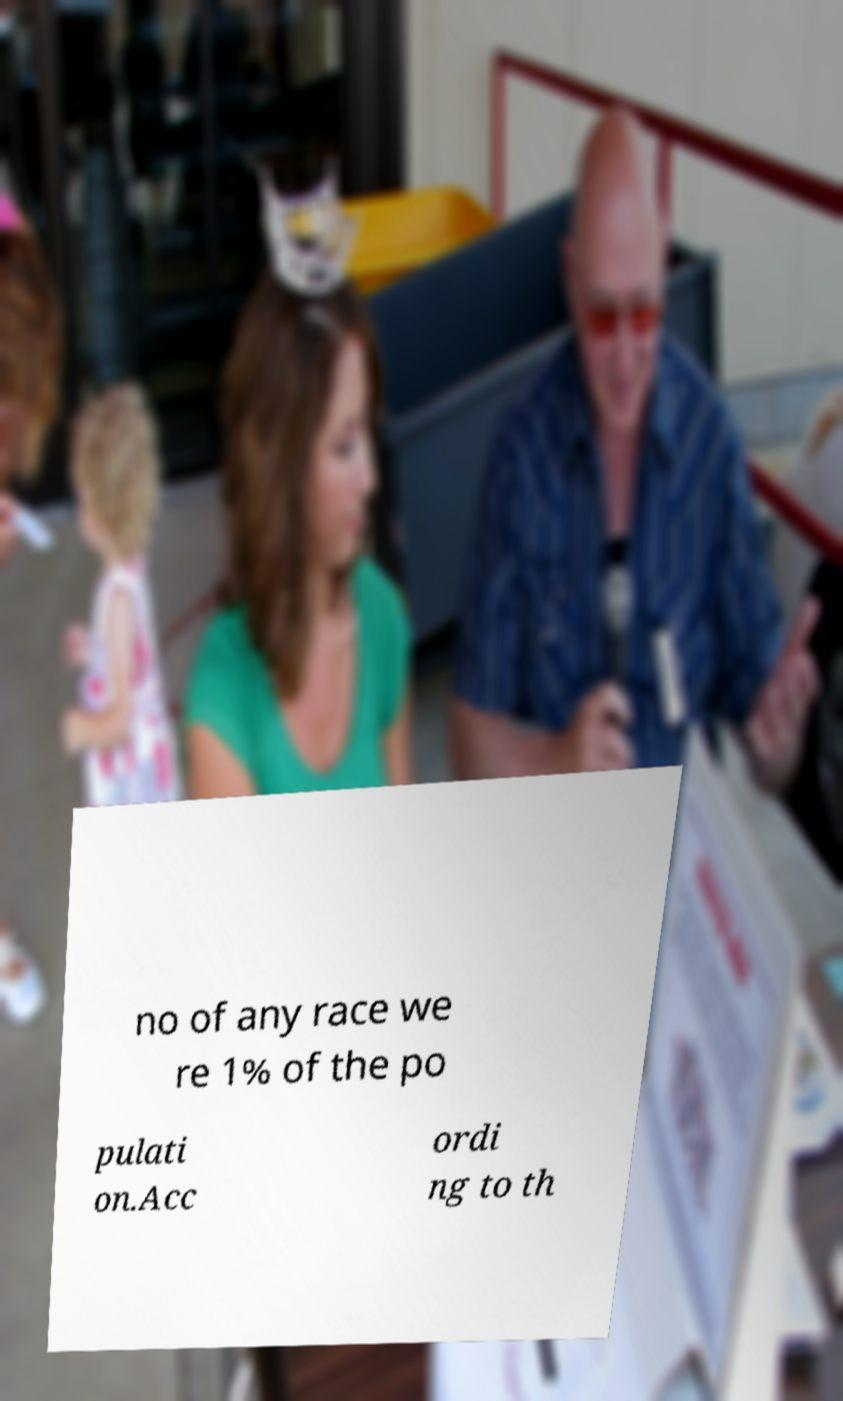For documentation purposes, I need the text within this image transcribed. Could you provide that? no of any race we re 1% of the po pulati on.Acc ordi ng to th 